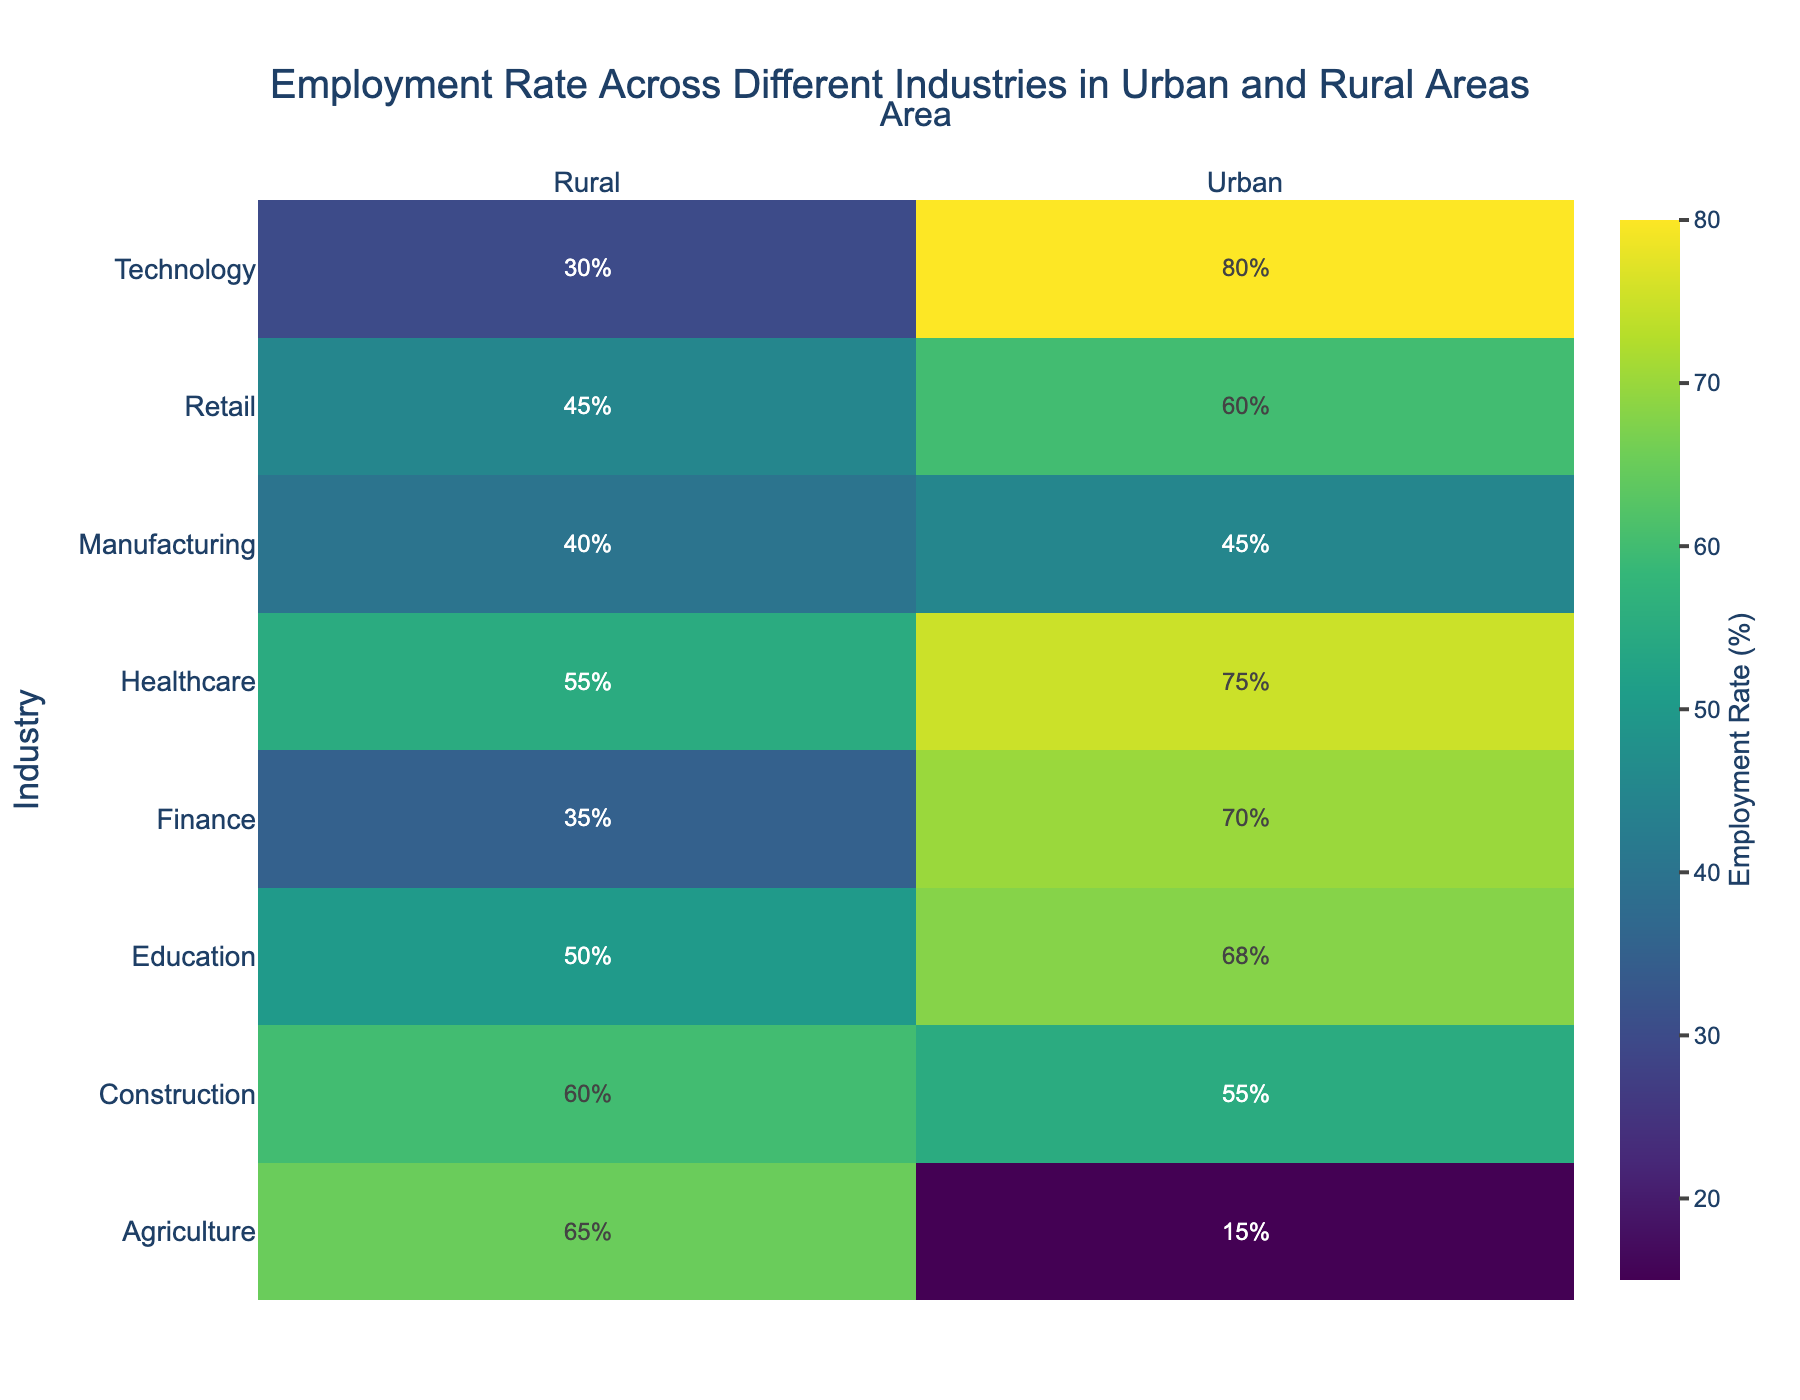What is the title of the heatmap? The title is the main text at the top of the heatmap that describes its content.
Answer: Employment Rate Across Different Industries in Urban and Rural Areas Which industry has the highest employment rate in urban areas? Look at the column labeled 'Urban' and identify the industry with the highest value.
Answer: Technology What is the employment rate for healthcare in rural areas? Find the row labeled 'Healthcare' and look at the value under the 'Rural' column.
Answer: 55 How much higher is the employment rate in urban agriculture compared to rural agriculture? Find the values for 'Agriculture' in both 'Urban' and 'Rural' columns and calculate the difference (Urban - Rural).
Answer: -50 Which area has a higher employment rate in the construction industry? Compare the values for 'Construction' in both 'Urban' and 'Rural' columns.
Answer: Rural What are the employment rates for Technology in both urban and rural areas? Find the row labeled 'Technology' and look at both 'Urban' and 'Rural' columns.
Answer: Urban: 80, Rural: 30 Which industries have an urban employment rate above 60? Check each value in the 'Urban' column and list industries that have values greater than 60.
Answer: Healthcare, Education, Technology, Finance What is the average employment rate across all industries in rural areas? Sum all the values in the 'Rural' column and divide by the number of industries (8).
Answer: (65 + 40 + 55 + 50 + 30 + 45 + 35 + 60) / 8 = 47.5 Is the employment rate for manufacturing higher in urban or rural areas? Compare the values for 'Manufacturing' in both columns.
Answer: Urban Which industry shows the most balanced employment rate between urban and rural areas? Look for the industry with the smallest difference in employment rates between 'Urban' and 'Rural'.
Answer: Construction 